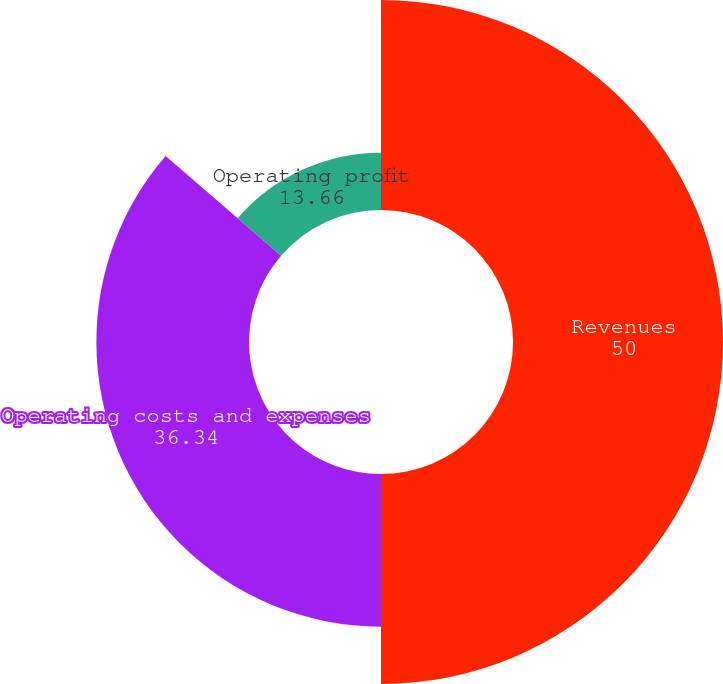<chart> <loc_0><loc_0><loc_500><loc_500><pie_chart><fcel>Revenues<fcel>Operating costs and expenses<fcel>Operating profit<nl><fcel>50.0%<fcel>36.34%<fcel>13.66%<nl></chart> 